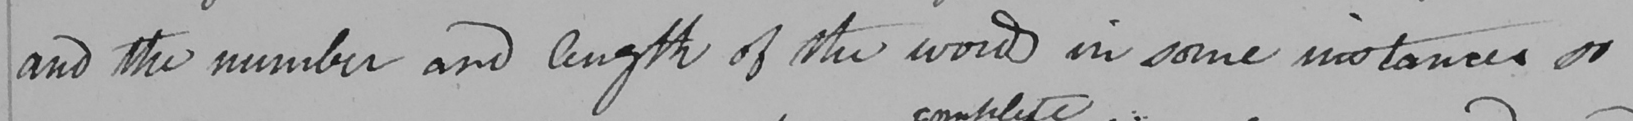Please transcribe the handwritten text in this image. and the number and length of the words in some instances so 